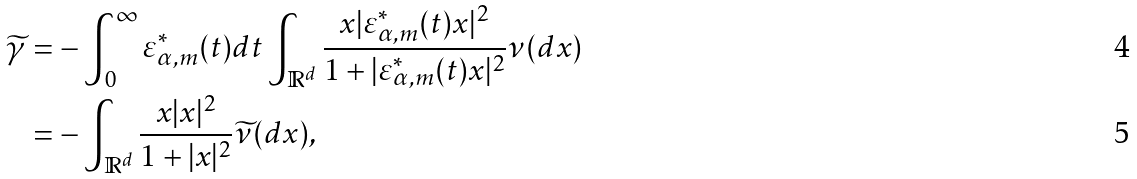<formula> <loc_0><loc_0><loc_500><loc_500>\widetilde { \gamma } & = - \int _ { 0 } ^ { \infty } \varepsilon _ { \alpha , m } ^ { \ast } ( t ) d t \int _ { \mathbb { R } ^ { d } } \frac { x | \varepsilon _ { \alpha , m } ^ { \ast } ( t ) x | ^ { 2 } } { 1 + | \varepsilon _ { \alpha , m } ^ { \ast } ( t ) x | ^ { 2 } } \nu ( d x ) \\ & = - \int _ { \mathbb { R } ^ { d } } \frac { x | x | ^ { 2 } } { 1 + | x | ^ { 2 } } \widetilde { \nu } ( d x ) ,</formula> 